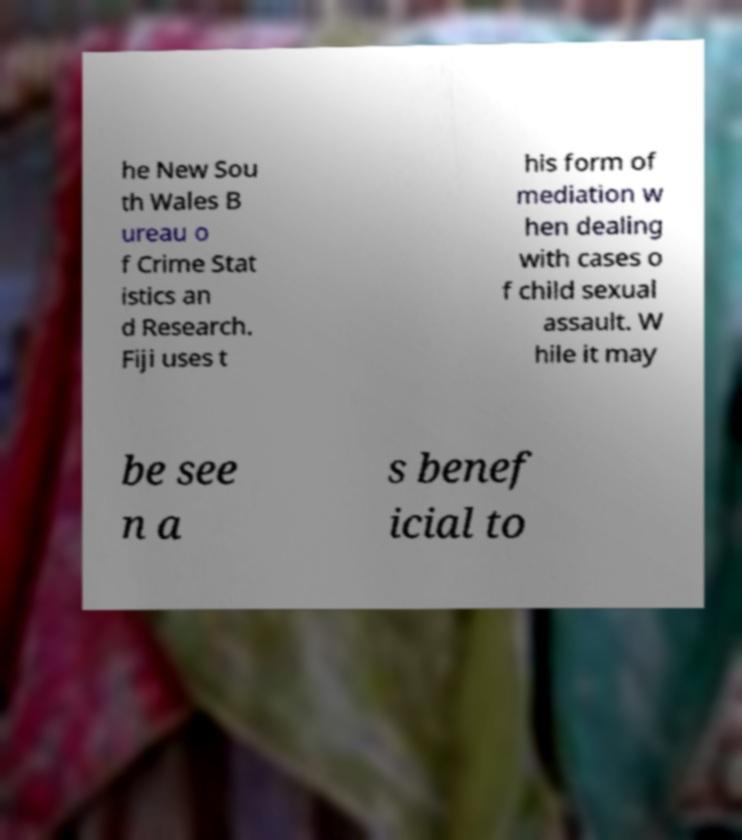I need the written content from this picture converted into text. Can you do that? he New Sou th Wales B ureau o f Crime Stat istics an d Research. Fiji uses t his form of mediation w hen dealing with cases o f child sexual assault. W hile it may be see n a s benef icial to 